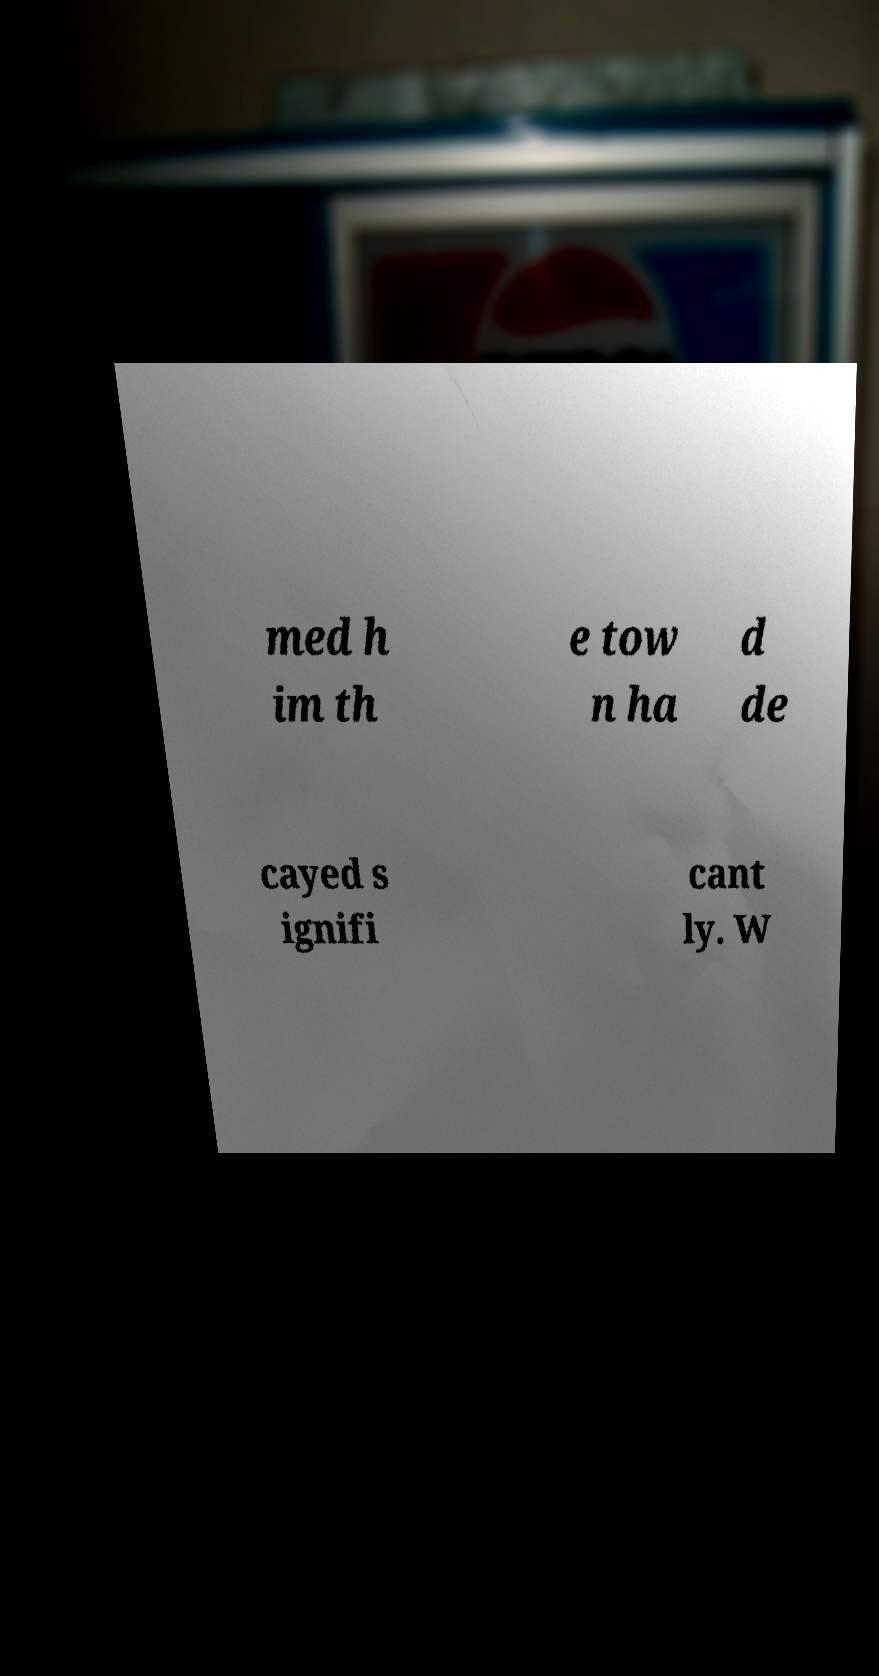For documentation purposes, I need the text within this image transcribed. Could you provide that? med h im th e tow n ha d de cayed s ignifi cant ly. W 